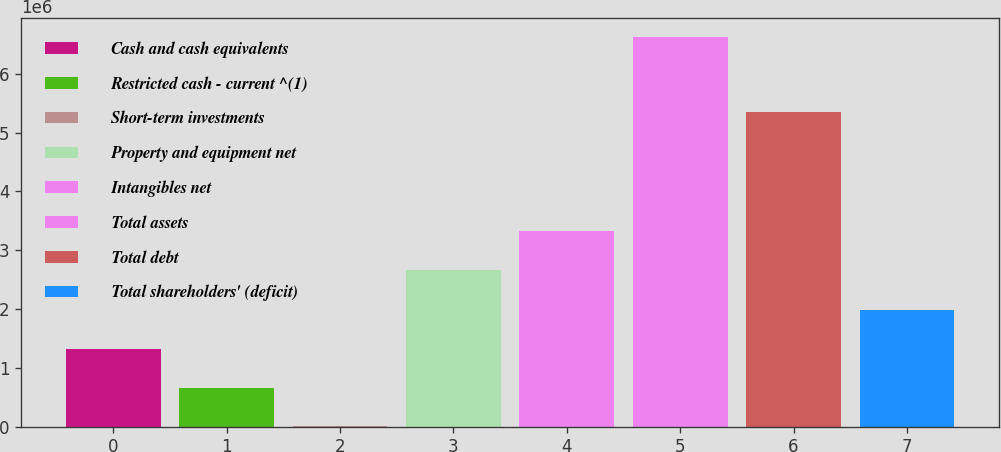Convert chart to OTSL. <chart><loc_0><loc_0><loc_500><loc_500><bar_chart><fcel>Cash and cash equivalents<fcel>Restricted cash - current ^(1)<fcel>Short-term investments<fcel>Property and equipment net<fcel>Intangibles net<fcel>Total assets<fcel>Total debt<fcel>Total shareholders' (deficit)<nl><fcel>1.32756e+06<fcel>666515<fcel>5471<fcel>2.67132e+06<fcel>3.33236e+06<fcel>6.61591e+06<fcel>5.3561e+06<fcel>1.9886e+06<nl></chart> 